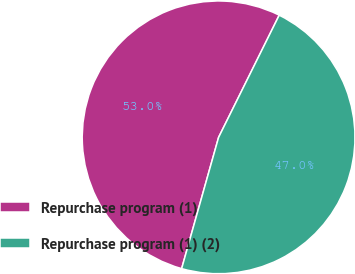Convert chart to OTSL. <chart><loc_0><loc_0><loc_500><loc_500><pie_chart><fcel>Repurchase program (1)<fcel>Repurchase program (1) (2)<nl><fcel>52.96%<fcel>47.04%<nl></chart> 